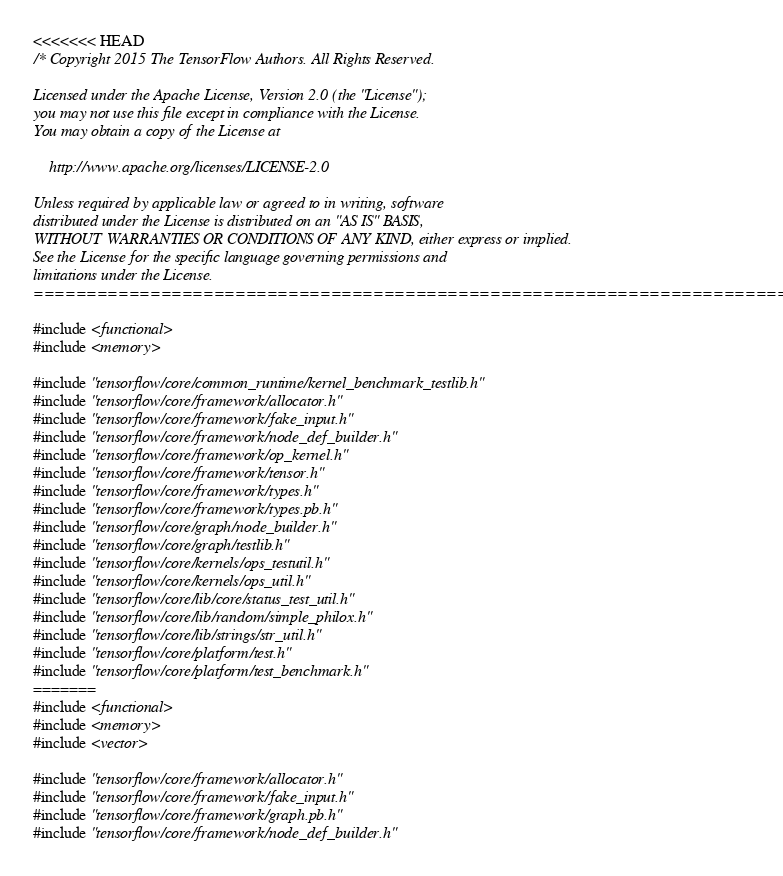<code> <loc_0><loc_0><loc_500><loc_500><_C++_><<<<<<< HEAD
/* Copyright 2015 The TensorFlow Authors. All Rights Reserved.

Licensed under the Apache License, Version 2.0 (the "License");
you may not use this file except in compliance with the License.
You may obtain a copy of the License at

    http://www.apache.org/licenses/LICENSE-2.0

Unless required by applicable law or agreed to in writing, software
distributed under the License is distributed on an "AS IS" BASIS,
WITHOUT WARRANTIES OR CONDITIONS OF ANY KIND, either express or implied.
See the License for the specific language governing permissions and
limitations under the License.
==============================================================================*/

#include <functional>
#include <memory>

#include "tensorflow/core/common_runtime/kernel_benchmark_testlib.h"
#include "tensorflow/core/framework/allocator.h"
#include "tensorflow/core/framework/fake_input.h"
#include "tensorflow/core/framework/node_def_builder.h"
#include "tensorflow/core/framework/op_kernel.h"
#include "tensorflow/core/framework/tensor.h"
#include "tensorflow/core/framework/types.h"
#include "tensorflow/core/framework/types.pb.h"
#include "tensorflow/core/graph/node_builder.h"
#include "tensorflow/core/graph/testlib.h"
#include "tensorflow/core/kernels/ops_testutil.h"
#include "tensorflow/core/kernels/ops_util.h"
#include "tensorflow/core/lib/core/status_test_util.h"
#include "tensorflow/core/lib/random/simple_philox.h"
#include "tensorflow/core/lib/strings/str_util.h"
#include "tensorflow/core/platform/test.h"
#include "tensorflow/core/platform/test_benchmark.h"
=======
#include <functional>
#include <memory>
#include <vector>

#include "tensorflow/core/framework/allocator.h"
#include "tensorflow/core/framework/fake_input.h"
#include "tensorflow/core/framework/graph.pb.h"
#include "tensorflow/core/framework/node_def_builder.h"</code> 